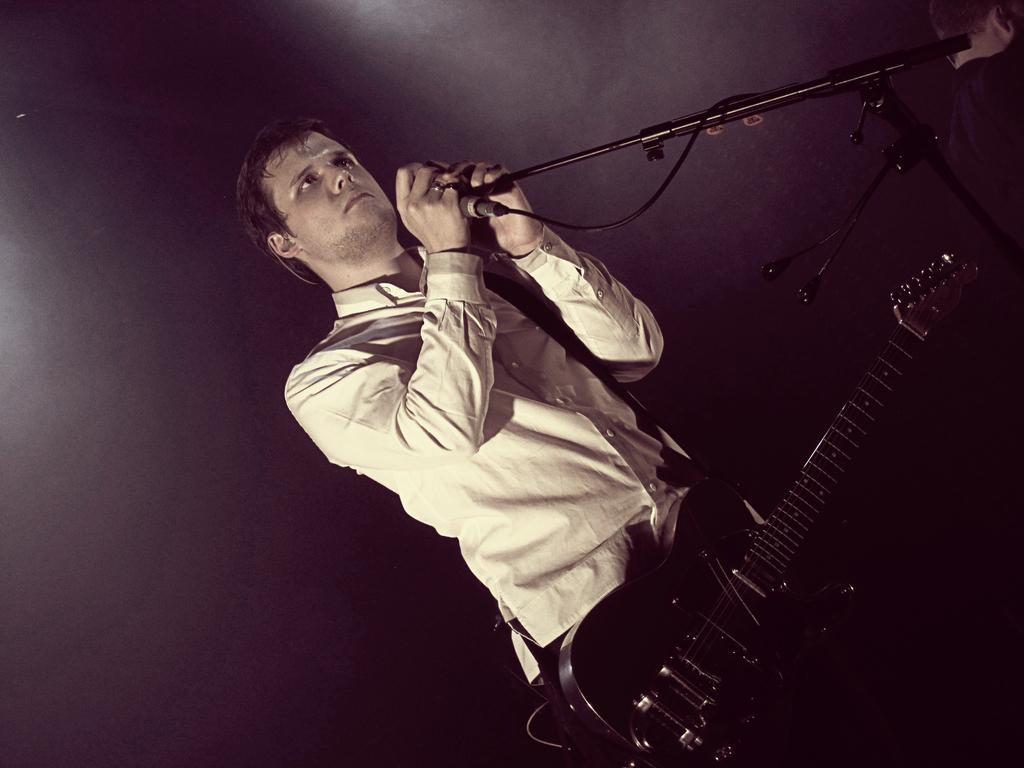Could you give a brief overview of what you see in this image? This picture seems to be of inside. In the center we can see a man wearing white color shirt, a guitar, holding a microphone and standing and a microphone is attached to the stand. On the top right corner we can see another person. The background is dark which seems to be a wall. 